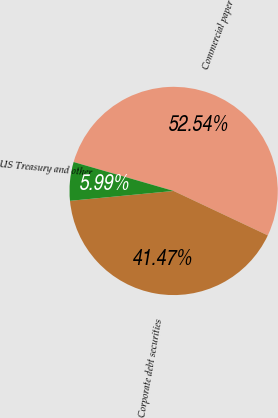Convert chart to OTSL. <chart><loc_0><loc_0><loc_500><loc_500><pie_chart><fcel>Commercial paper<fcel>Corporate debt securities<fcel>US Treasury and other<nl><fcel>52.53%<fcel>41.47%<fcel>5.99%<nl></chart> 